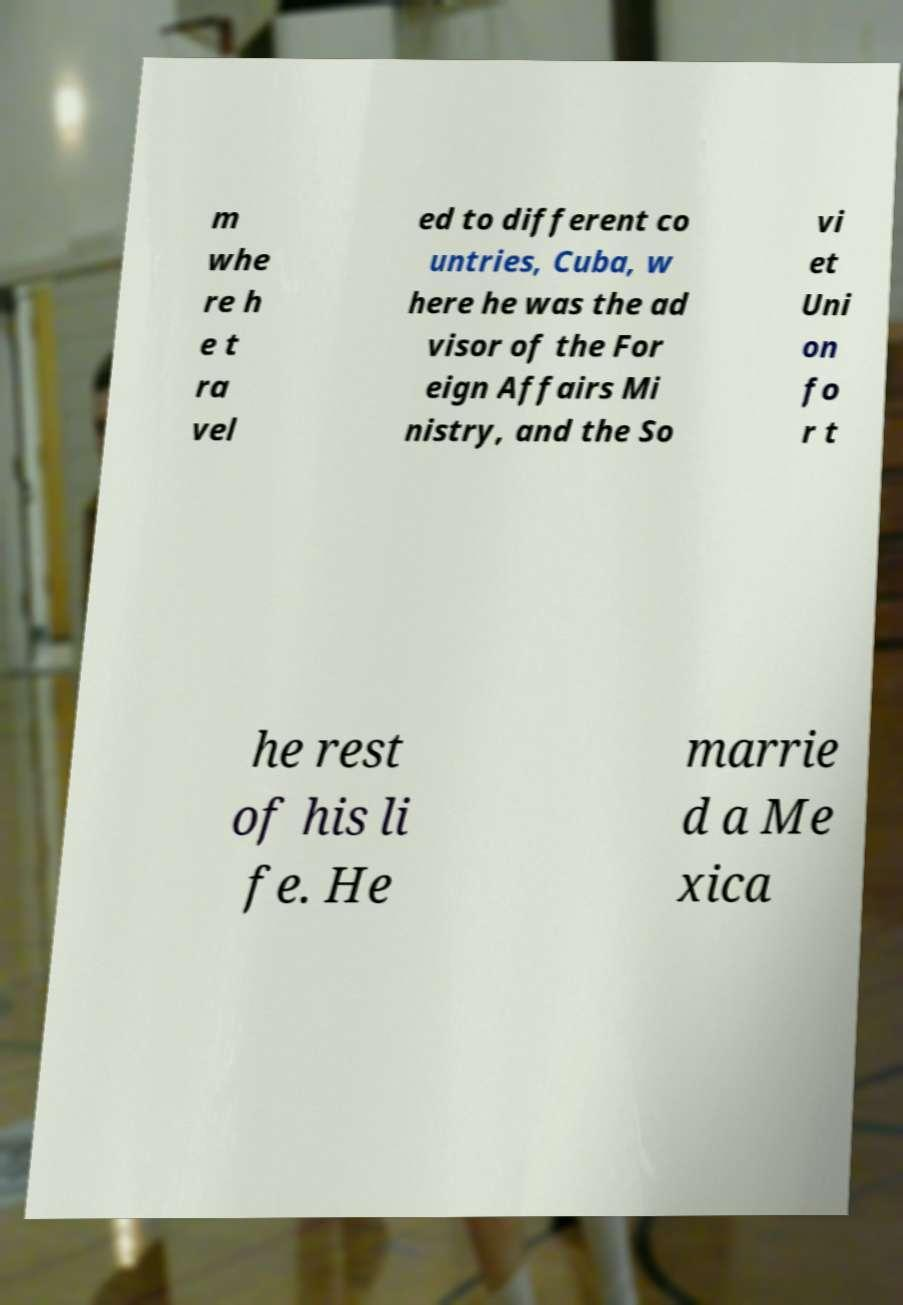What messages or text are displayed in this image? I need them in a readable, typed format. m whe re h e t ra vel ed to different co untries, Cuba, w here he was the ad visor of the For eign Affairs Mi nistry, and the So vi et Uni on fo r t he rest of his li fe. He marrie d a Me xica 